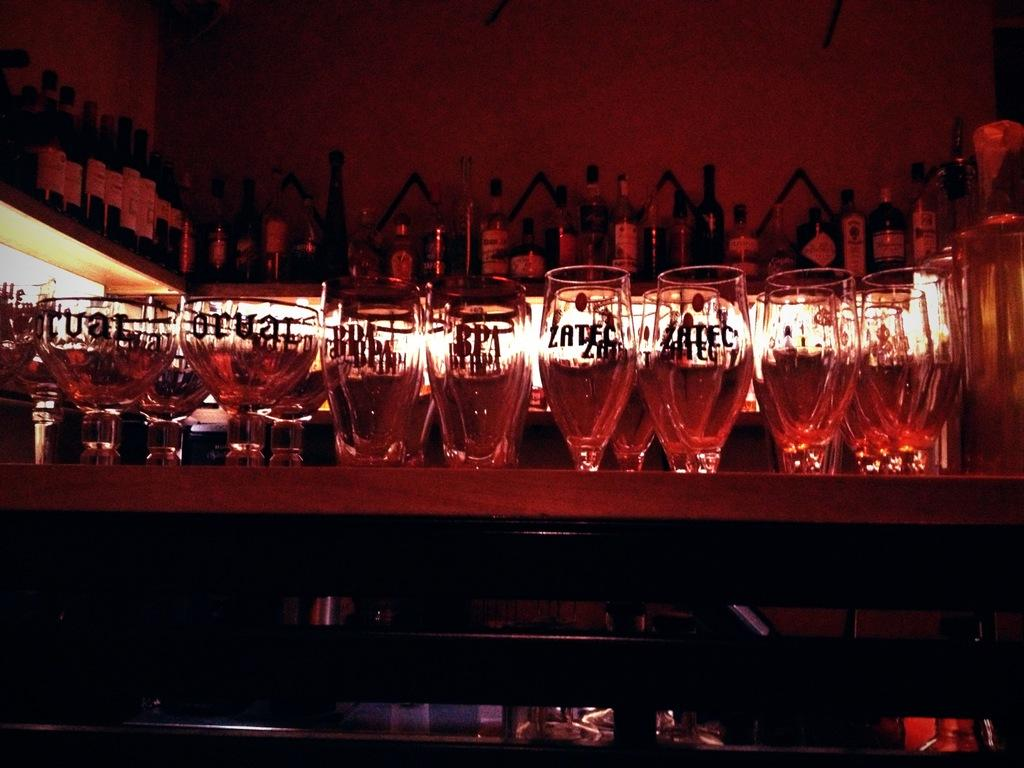What objects are on the table in the image? There is a group of glasses on a table in the image. What can be seen in the background of the image? There are bottles on a rack and lights visible in the background. What type of disease is being treated in the image? There is no indication of a disease or treatment in the image; it features a group of glasses on a table and bottles on a rack in the background. 